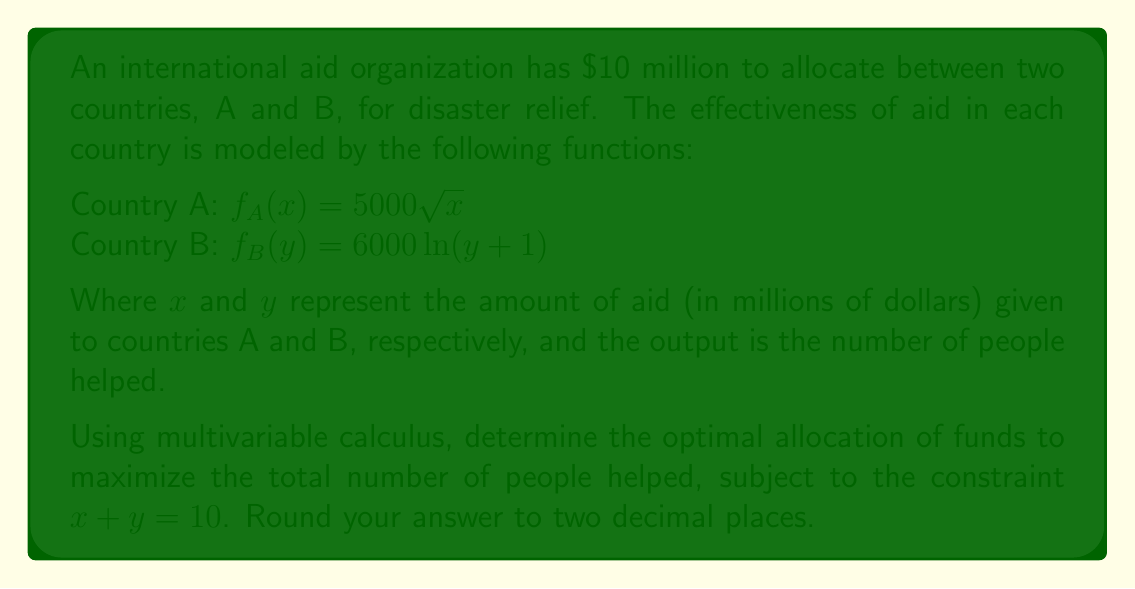Teach me how to tackle this problem. To solve this optimization problem, we'll use the method of Lagrange multipliers:

1) Define the function to be maximized:
   $F(x,y) = f_A(x) + f_B(y) = 5000\sqrt{x} + 6000\ln(y+1)$

2) Define the constraint function:
   $g(x,y) = x + y - 10 = 0$

3) Form the Lagrangian function:
   $L(x,y,\lambda) = F(x,y) - \lambda g(x,y)$
   $L(x,y,\lambda) = 5000\sqrt{x} + 6000\ln(y+1) - \lambda(x + y - 10)$

4) Compute partial derivatives and set them to zero:
   $\frac{\partial L}{\partial x} = \frac{2500}{\sqrt{x}} - \lambda = 0$
   $\frac{\partial L}{\partial y} = \frac{6000}{y+1} - \lambda = 0$
   $\frac{\partial L}{\partial \lambda} = x + y - 10 = 0$

5) From the first two equations:
   $\frac{2500}{\sqrt{x}} = \frac{6000}{y+1}$

6) Simplify:
   $\frac{25}{6} = \frac{\sqrt{x}}{y+1}$
   $(\frac{25}{6})^2 = \frac{x}{(y+1)^2}$
   $\frac{625}{36} = \frac{x}{(y+1)^2}$

7) Substitute $x = 10 - y$ from the constraint:
   $\frac{625}{36} = \frac{10-y}{(y+1)^2}$

8) Solve this equation numerically (using a computer algebra system or numerical methods):
   $y \approx 5.94$
   $x = 10 - y \approx 4.06$

9) Verify the second derivative test to confirm this is a maximum.

Therefore, the optimal allocation is approximately $4.06 million to Country A and $5.94 million to Country B.
Answer: $x \approx 4.06$, $y \approx 5.94$ 